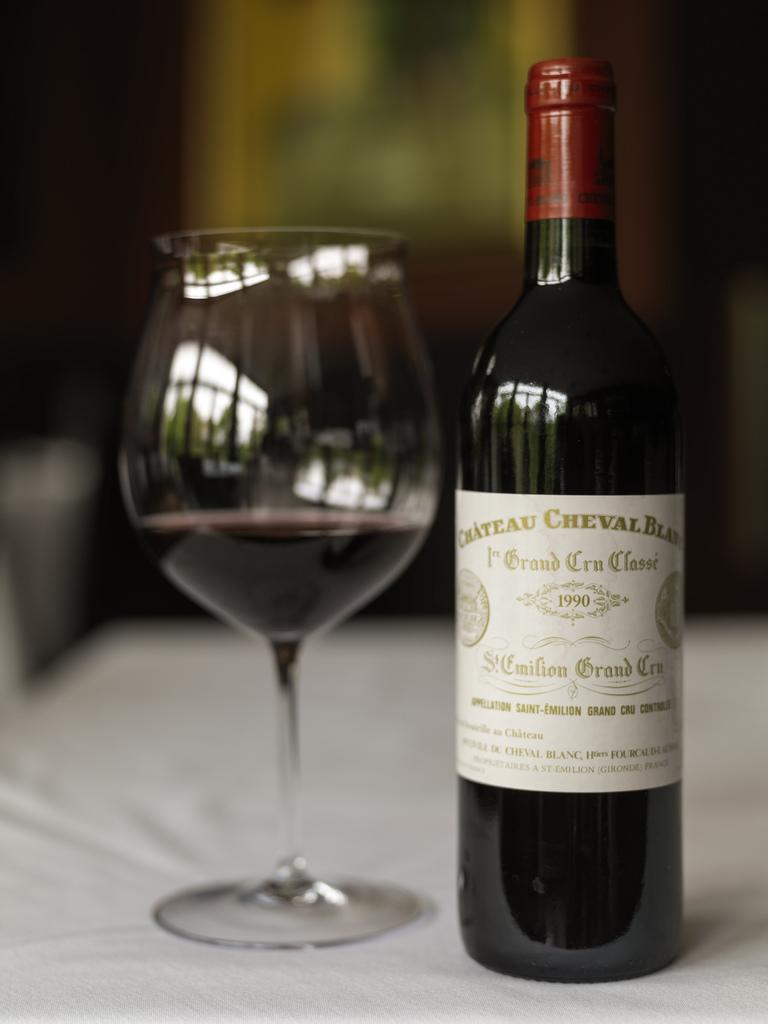What type of furniture is present in the image? There is a table in the image. What is covering the table? There is a white cloth on the table. What items are on the table? There is a wine glass and a wine bottle on the table. What can be inferred about the setting from the background colors? The background of the image includes black and yellow colors, which might suggest a specific theme or decor. What type of milk is being heated in the image? There is no milk or heating element present in the image. What game is being played in the image? There is no game or players visible in the image. 